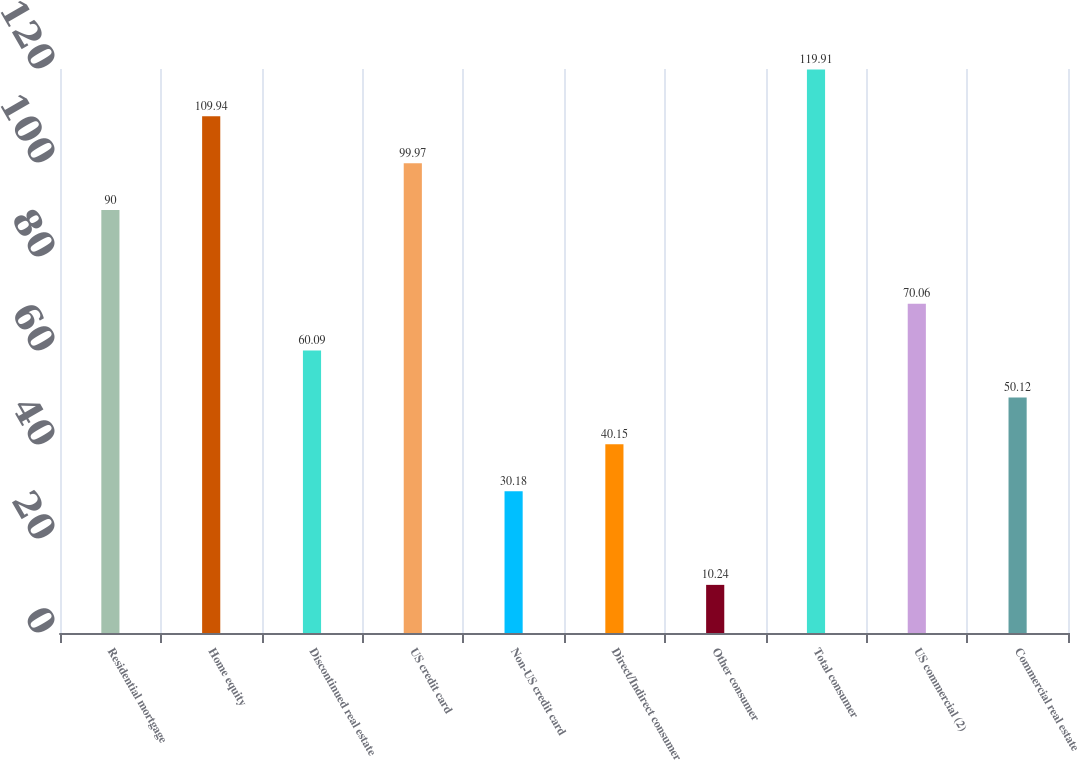Convert chart. <chart><loc_0><loc_0><loc_500><loc_500><bar_chart><fcel>Residential mortgage<fcel>Home equity<fcel>Discontinued real estate<fcel>US credit card<fcel>Non-US credit card<fcel>Direct/Indirect consumer<fcel>Other consumer<fcel>Total consumer<fcel>US commercial (2)<fcel>Commercial real estate<nl><fcel>90<fcel>109.94<fcel>60.09<fcel>99.97<fcel>30.18<fcel>40.15<fcel>10.24<fcel>119.91<fcel>70.06<fcel>50.12<nl></chart> 